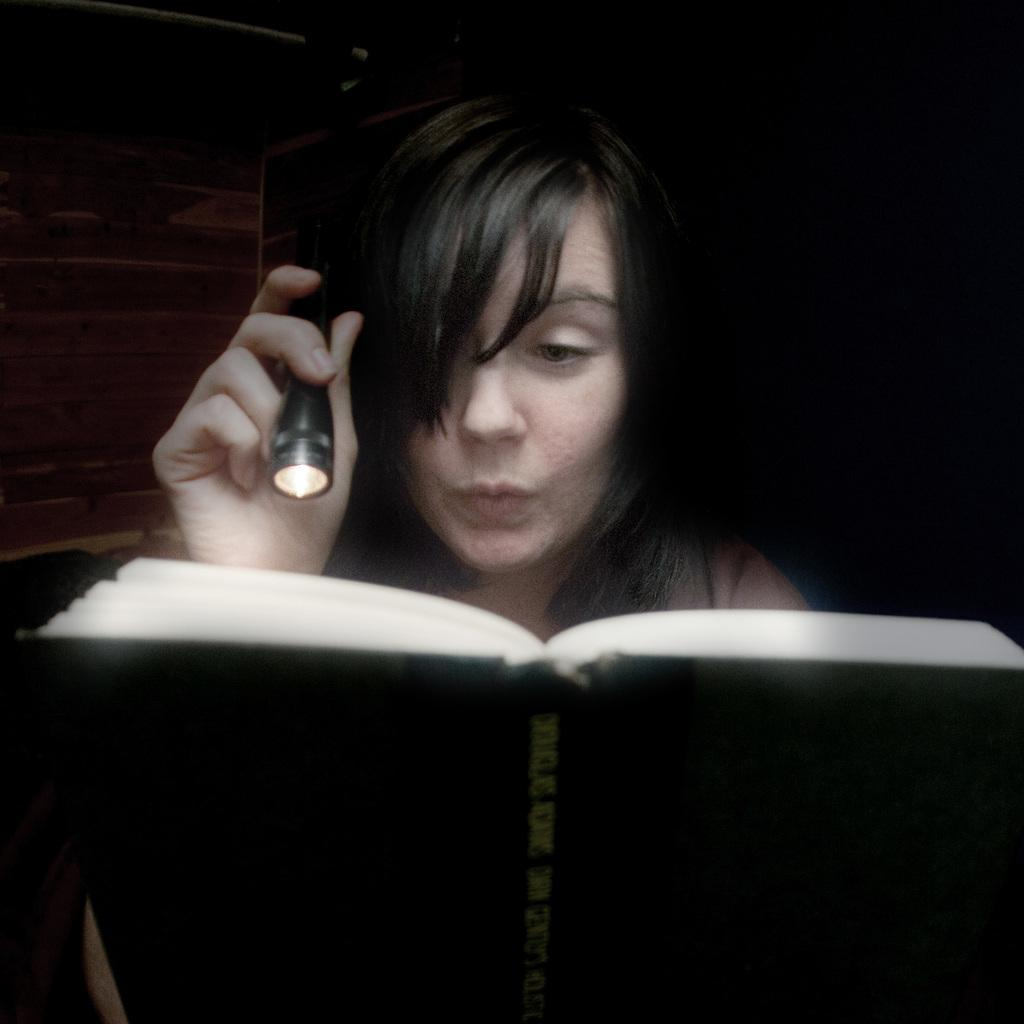Who is present in the image? There is a woman in the image. What is the woman holding in her hands? The woman is holding a book and a torch. What can be inferred about the lighting conditions in the image? The background of the image is completely dark. What type of rose can be seen in the image? There is no rose present in the image. How does the woman use the toothpaste in the image? There is no toothpaste present in the image. 